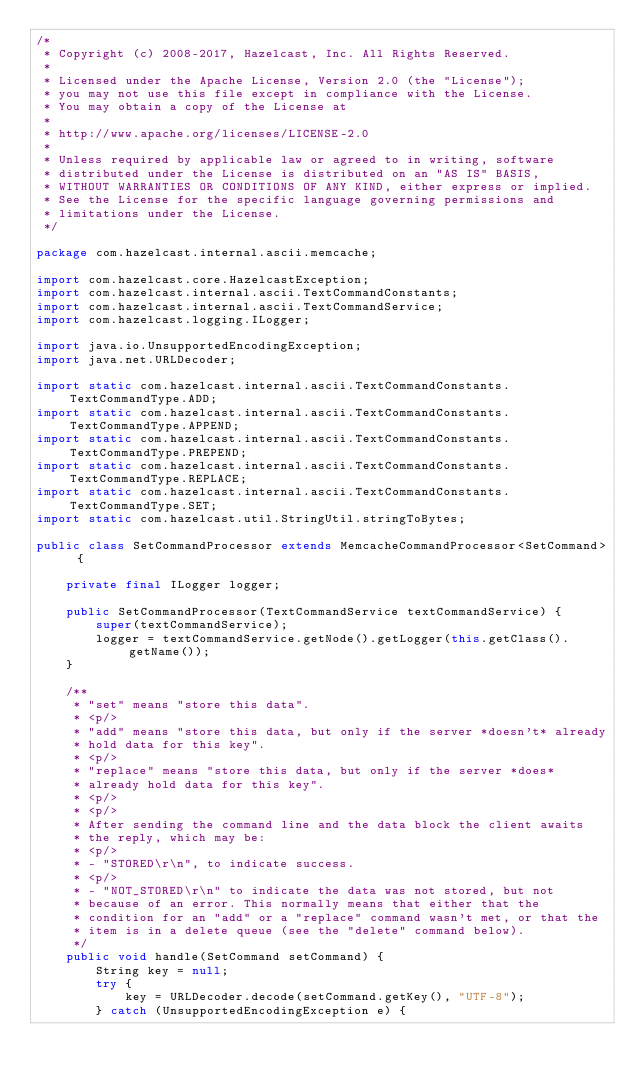<code> <loc_0><loc_0><loc_500><loc_500><_Java_>/*
 * Copyright (c) 2008-2017, Hazelcast, Inc. All Rights Reserved.
 *
 * Licensed under the Apache License, Version 2.0 (the "License");
 * you may not use this file except in compliance with the License.
 * You may obtain a copy of the License at
 *
 * http://www.apache.org/licenses/LICENSE-2.0
 *
 * Unless required by applicable law or agreed to in writing, software
 * distributed under the License is distributed on an "AS IS" BASIS,
 * WITHOUT WARRANTIES OR CONDITIONS OF ANY KIND, either express or implied.
 * See the License for the specific language governing permissions and
 * limitations under the License.
 */

package com.hazelcast.internal.ascii.memcache;

import com.hazelcast.core.HazelcastException;
import com.hazelcast.internal.ascii.TextCommandConstants;
import com.hazelcast.internal.ascii.TextCommandService;
import com.hazelcast.logging.ILogger;

import java.io.UnsupportedEncodingException;
import java.net.URLDecoder;

import static com.hazelcast.internal.ascii.TextCommandConstants.TextCommandType.ADD;
import static com.hazelcast.internal.ascii.TextCommandConstants.TextCommandType.APPEND;
import static com.hazelcast.internal.ascii.TextCommandConstants.TextCommandType.PREPEND;
import static com.hazelcast.internal.ascii.TextCommandConstants.TextCommandType.REPLACE;
import static com.hazelcast.internal.ascii.TextCommandConstants.TextCommandType.SET;
import static com.hazelcast.util.StringUtil.stringToBytes;

public class SetCommandProcessor extends MemcacheCommandProcessor<SetCommand> {

    private final ILogger logger;

    public SetCommandProcessor(TextCommandService textCommandService) {
        super(textCommandService);
        logger = textCommandService.getNode().getLogger(this.getClass().getName());
    }

    /**
     * "set" means "store this data".
     * <p/>
     * "add" means "store this data, but only if the server *doesn't* already
     * hold data for this key".
     * <p/>
     * "replace" means "store this data, but only if the server *does*
     * already hold data for this key".
     * <p/>
     * <p/>
     * After sending the command line and the data block the client awaits
     * the reply, which may be:
     * <p/>
     * - "STORED\r\n", to indicate success.
     * <p/>
     * - "NOT_STORED\r\n" to indicate the data was not stored, but not
     * because of an error. This normally means that either that the
     * condition for an "add" or a "replace" command wasn't met, or that the
     * item is in a delete queue (see the "delete" command below).
     */
    public void handle(SetCommand setCommand) {
        String key = null;
        try {
            key = URLDecoder.decode(setCommand.getKey(), "UTF-8");
        } catch (UnsupportedEncodingException e) {</code> 